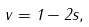Convert formula to latex. <formula><loc_0><loc_0><loc_500><loc_500>v = 1 - 2 s ,</formula> 